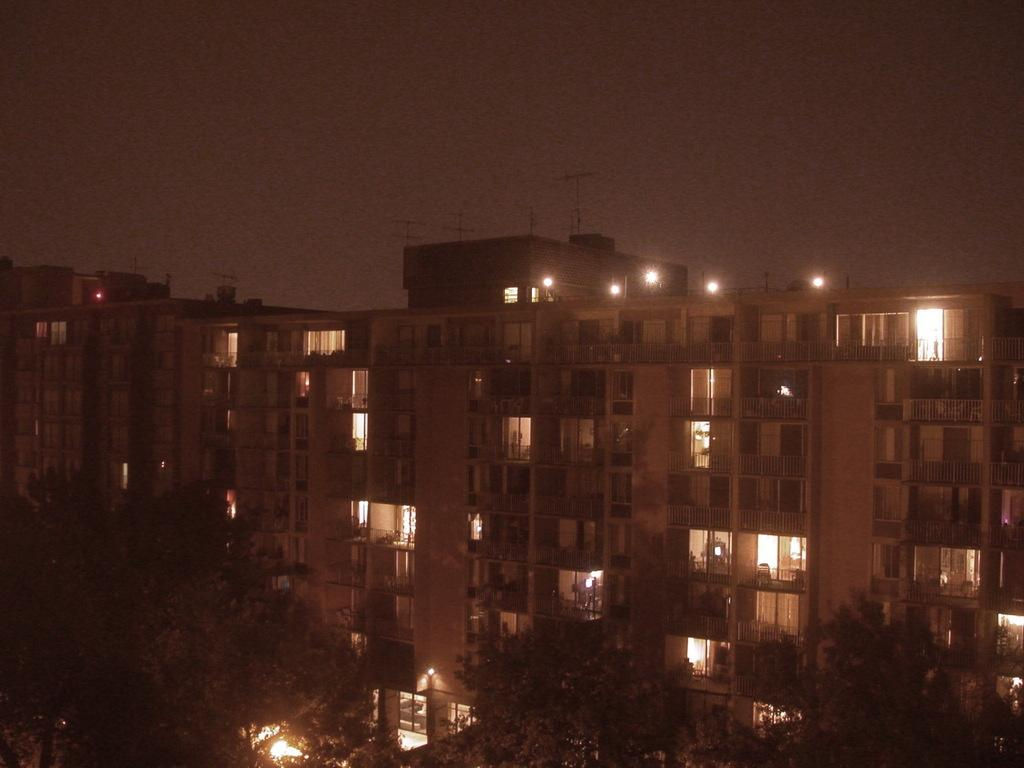What type of vegetation is present at the bottom of the image? There are trees at the bottom of the image. What structures can be seen in the background of the image? There are buildings and trees in the background of the image. What other objects are visible in the background of the image? There are poles, windows, and light poles on the buildings in the background of the image. What part of the natural environment is visible in the background of the image? The sky is visible in the background of the image. What type of knowledge is being shared by the ghost in the image? There is no ghost present in the image, so no knowledge can be shared. What type of business is being conducted in the image? The image does not depict any specific business activity, so it cannot be determined from the image. 